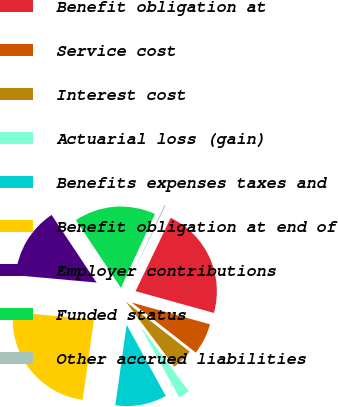Convert chart to OTSL. <chart><loc_0><loc_0><loc_500><loc_500><pie_chart><fcel>Benefit obligation at<fcel>Service cost<fcel>Interest cost<fcel>Actuarial loss (gain)<fcel>Benefits expenses taxes and<fcel>Benefit obligation at end of<fcel>Employer contributions<fcel>Funded status<fcel>Other accrued liabilities<nl><fcel>22.21%<fcel>6.23%<fcel>4.23%<fcel>2.23%<fcel>10.22%<fcel>24.21%<fcel>14.22%<fcel>16.22%<fcel>0.23%<nl></chart> 